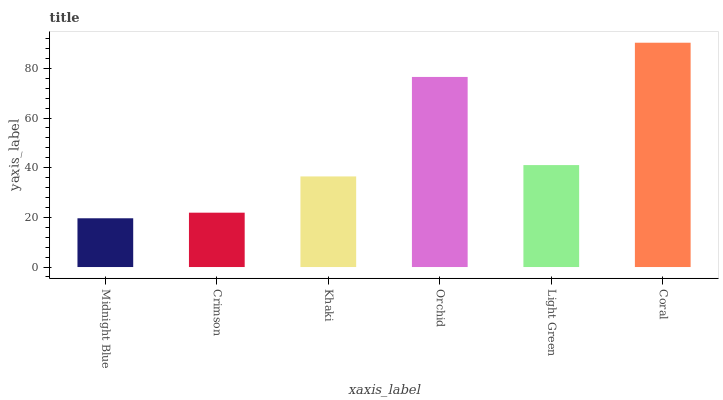Is Crimson the minimum?
Answer yes or no. No. Is Crimson the maximum?
Answer yes or no. No. Is Crimson greater than Midnight Blue?
Answer yes or no. Yes. Is Midnight Blue less than Crimson?
Answer yes or no. Yes. Is Midnight Blue greater than Crimson?
Answer yes or no. No. Is Crimson less than Midnight Blue?
Answer yes or no. No. Is Light Green the high median?
Answer yes or no. Yes. Is Khaki the low median?
Answer yes or no. Yes. Is Khaki the high median?
Answer yes or no. No. Is Midnight Blue the low median?
Answer yes or no. No. 